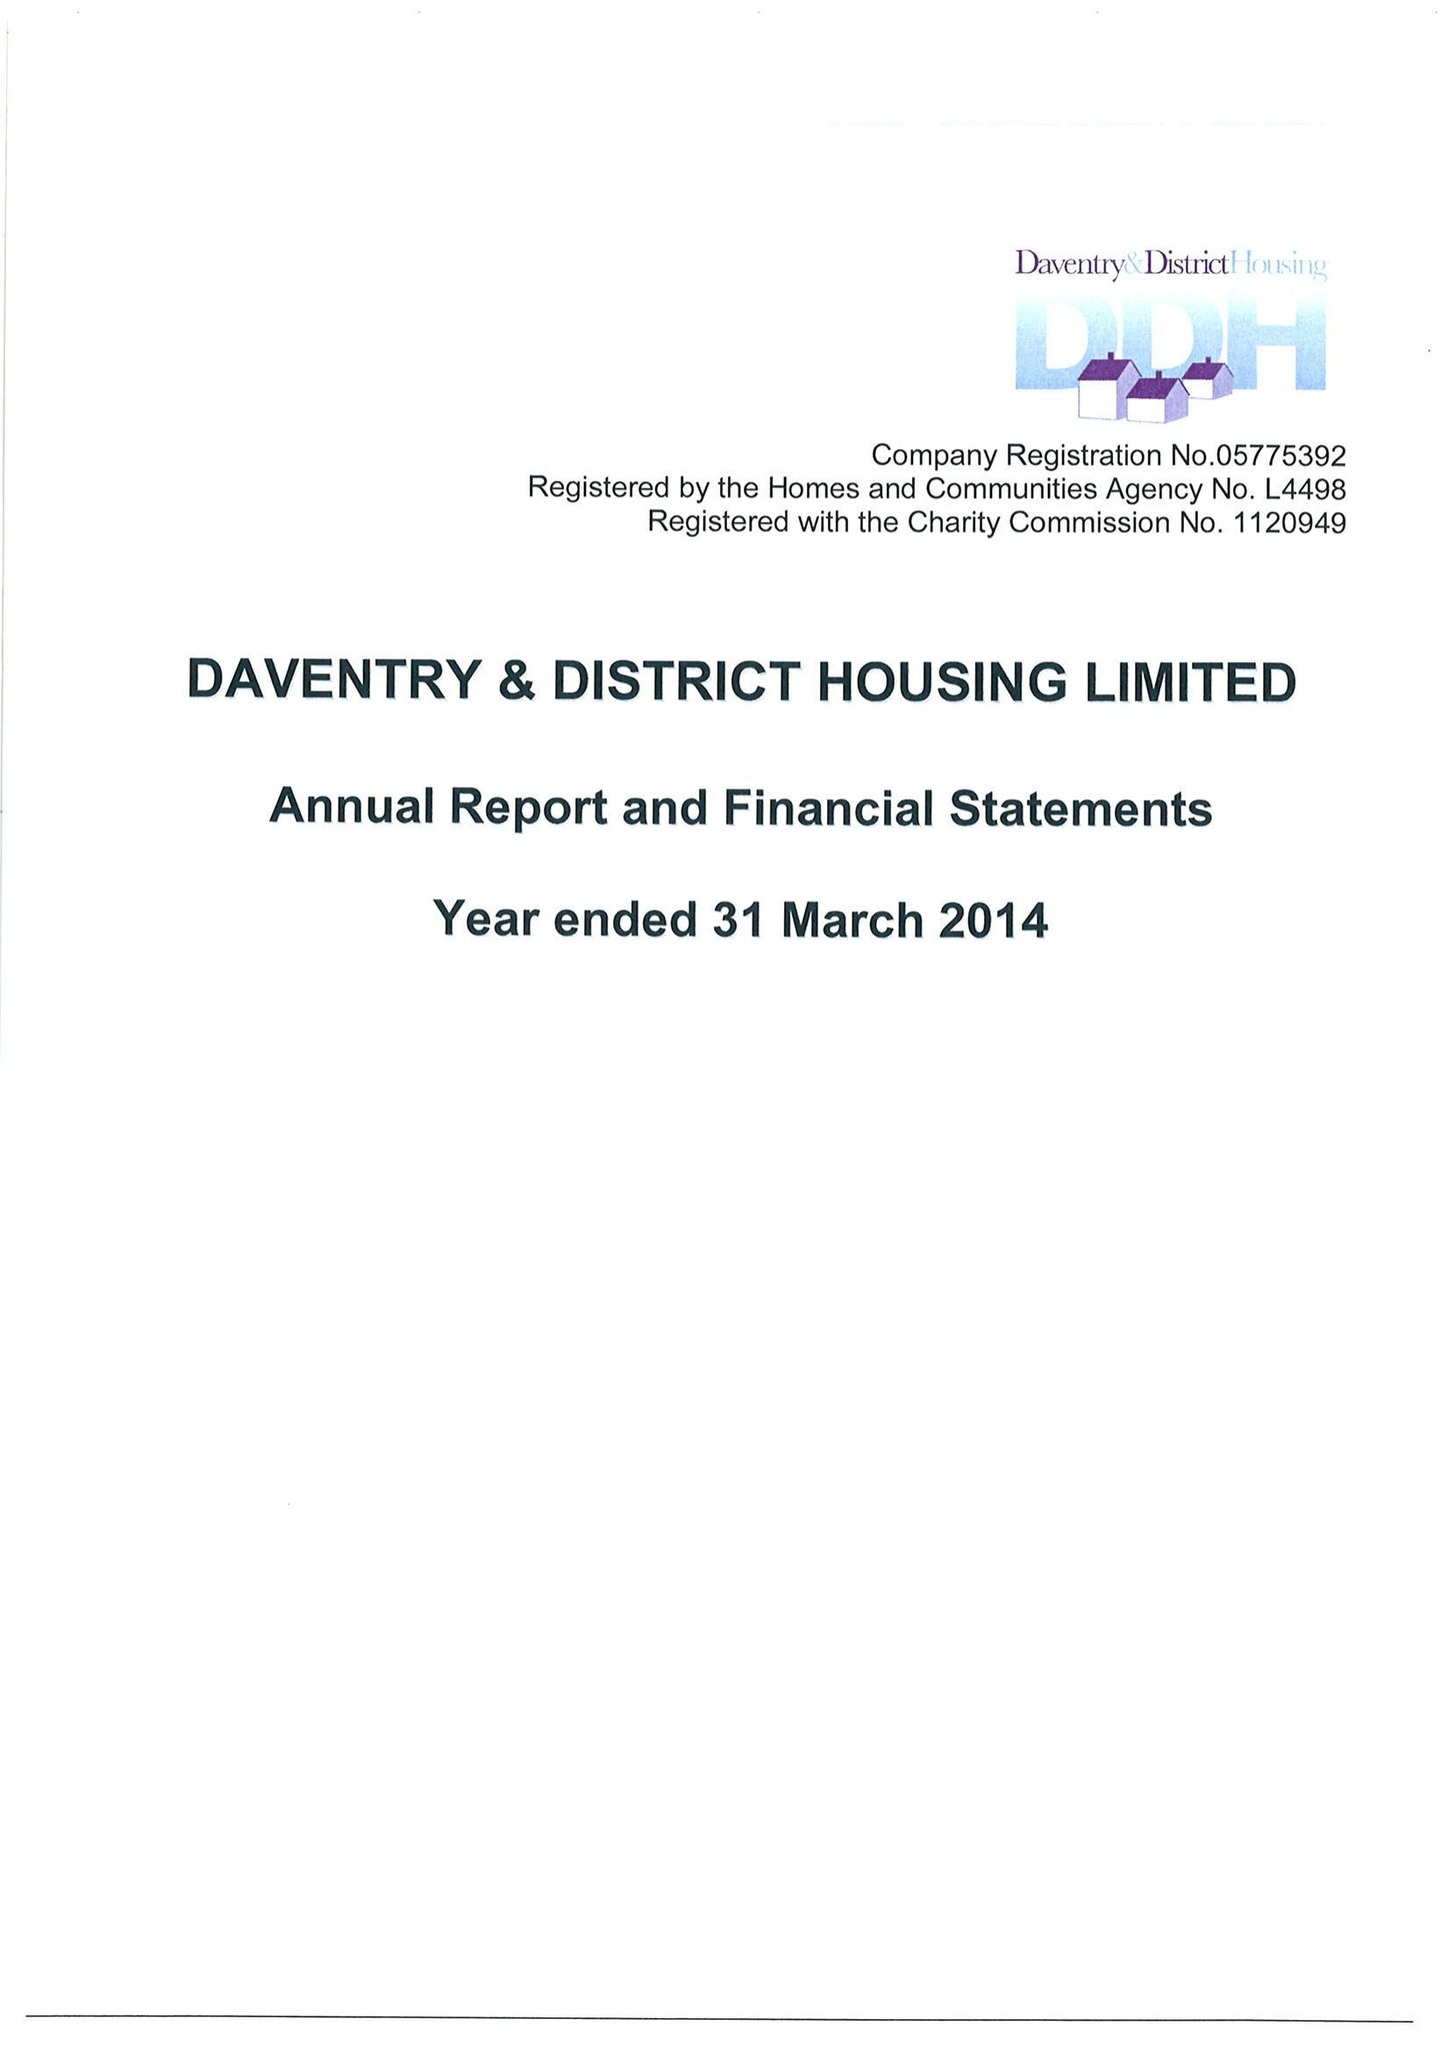What is the value for the income_annually_in_british_pounds?
Answer the question using a single word or phrase. 15309000.00 